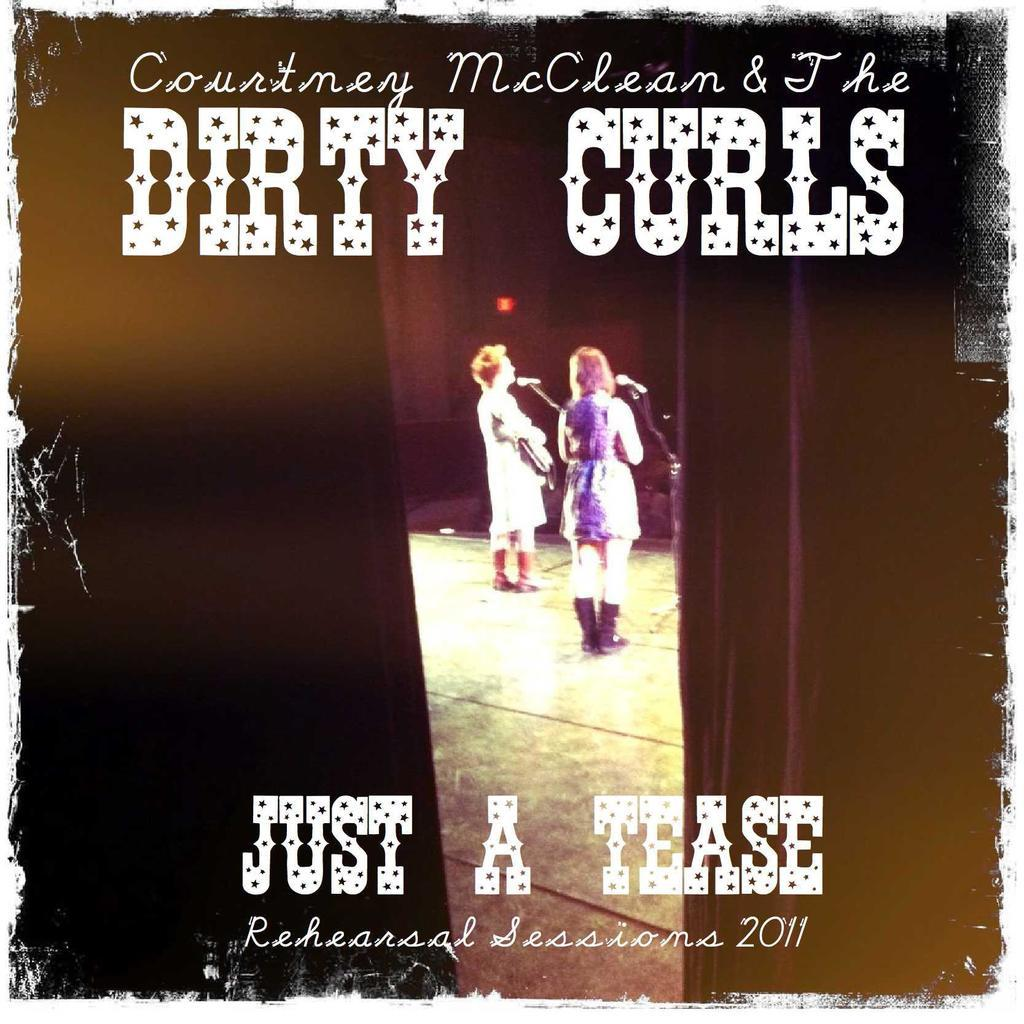Provide a one-sentence caption for the provided image. A poster for the group Courtney McClean and The Dirty Curls shows people singing on stage. 